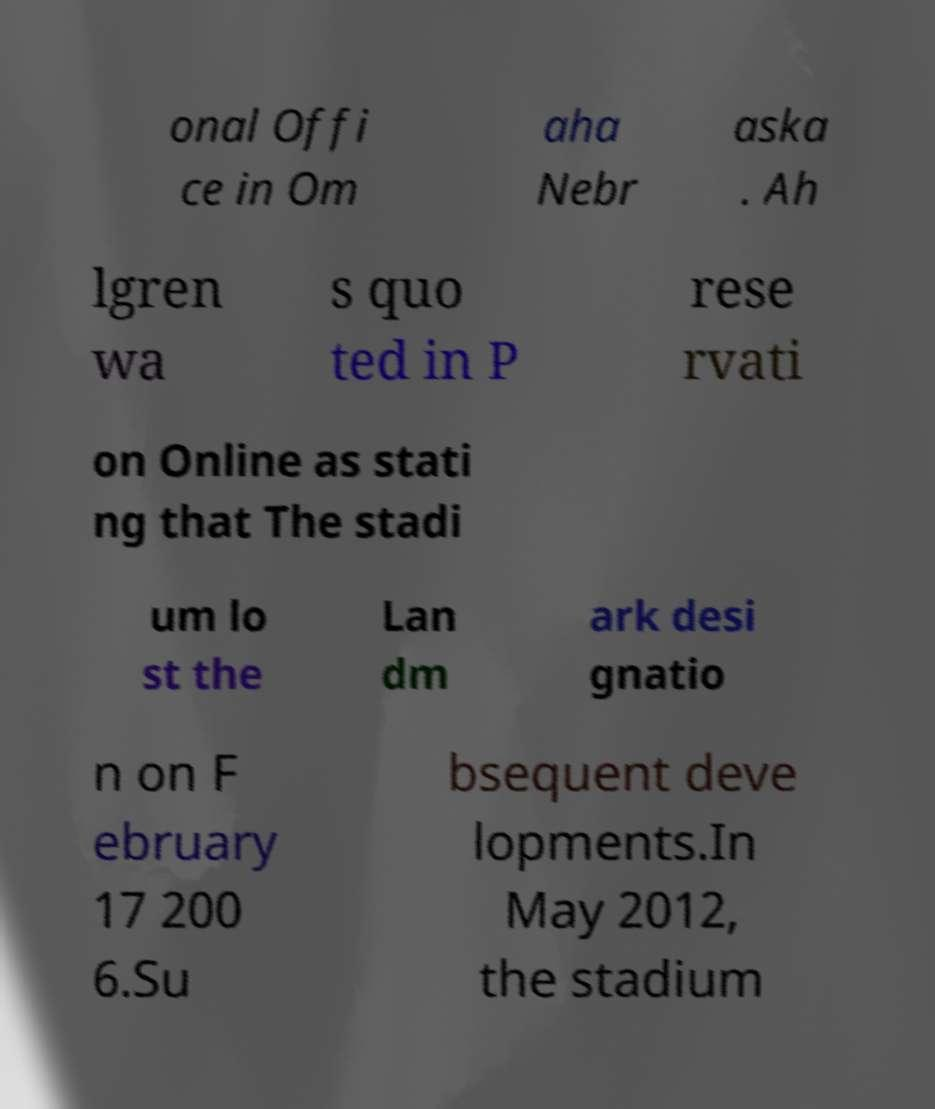Please identify and transcribe the text found in this image. onal Offi ce in Om aha Nebr aska . Ah lgren wa s quo ted in P rese rvati on Online as stati ng that The stadi um lo st the Lan dm ark desi gnatio n on F ebruary 17 200 6.Su bsequent deve lopments.In May 2012, the stadium 